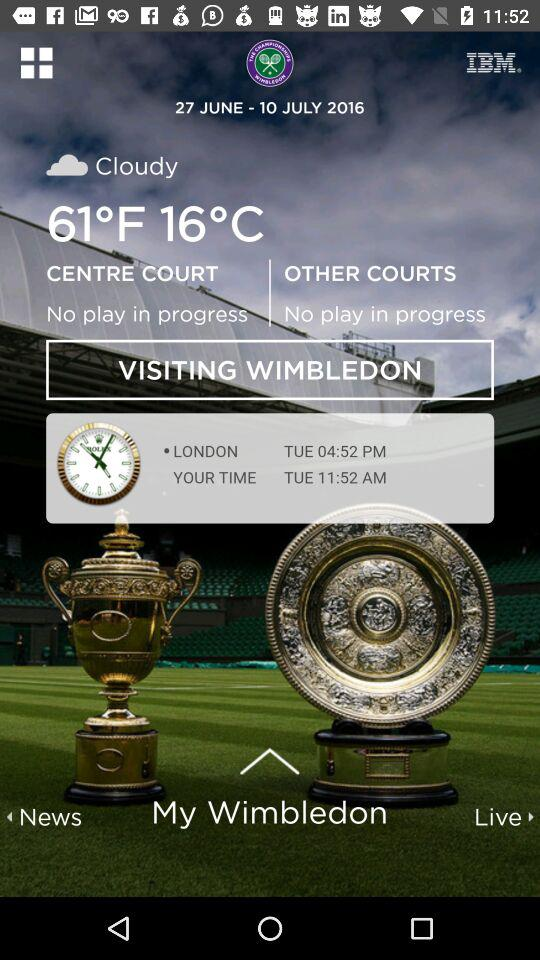What's the temperature? The temperatures are 61 °F and 16 °C. 